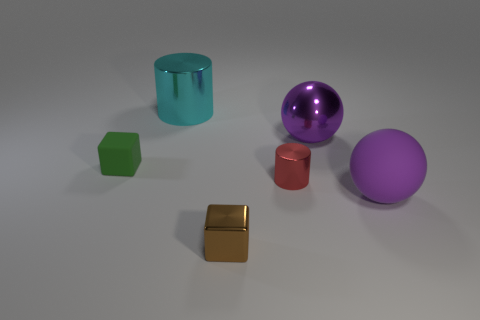Add 2 big cylinders. How many objects exist? 8 Subtract 1 cylinders. How many cylinders are left? 1 Add 1 cylinders. How many cylinders are left? 3 Add 3 brown metal things. How many brown metal things exist? 4 Subtract 0 red blocks. How many objects are left? 6 Subtract all cyan cylinders. Subtract all green cubes. How many cylinders are left? 1 Subtract all large gray metal blocks. Subtract all rubber cubes. How many objects are left? 5 